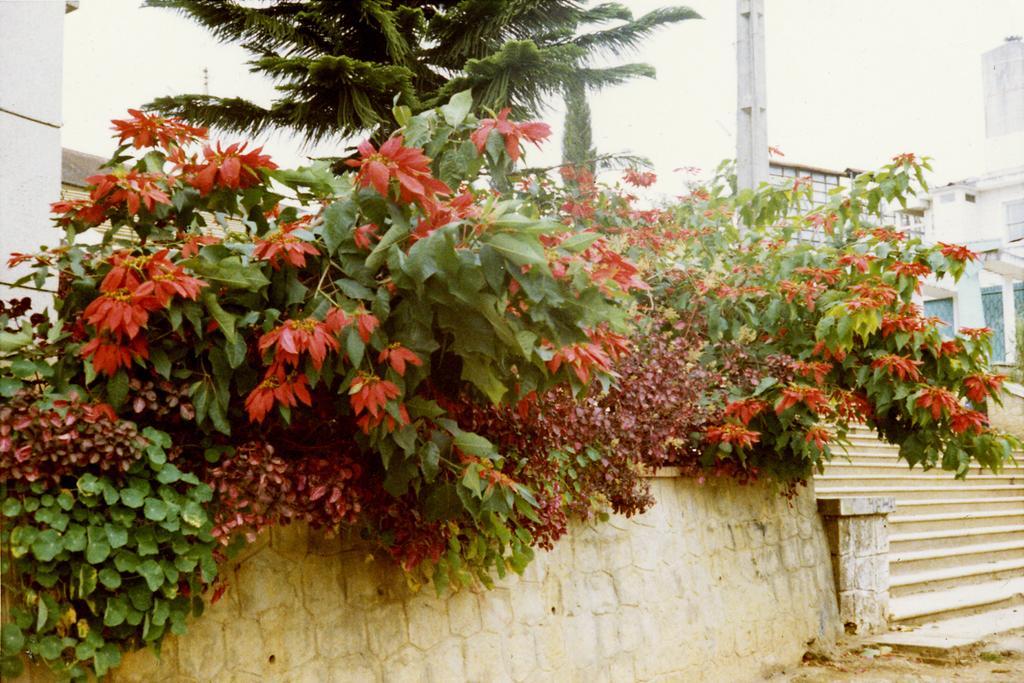How would you summarize this image in a sentence or two? In this picture there are flower plants in the center of the image and there are stairs on the right side of the image and there are buildings and trees in the background area of the image. 